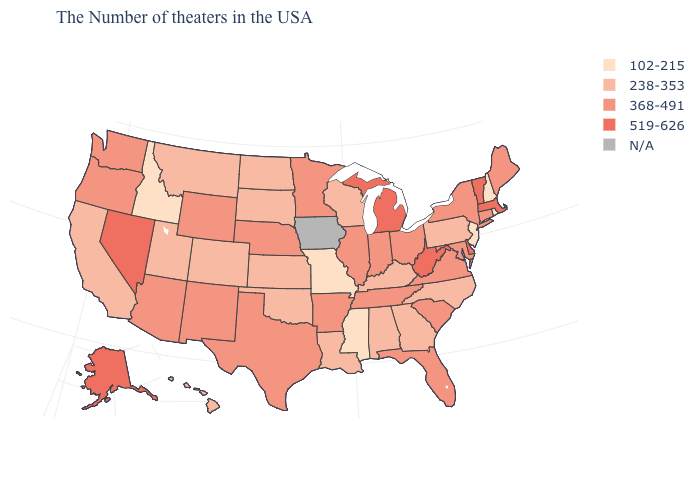What is the value of Georgia?
Give a very brief answer. 238-353. Is the legend a continuous bar?
Give a very brief answer. No. What is the lowest value in the USA?
Give a very brief answer. 102-215. Among the states that border Maine , which have the lowest value?
Concise answer only. New Hampshire. What is the value of Hawaii?
Short answer required. 238-353. Among the states that border Louisiana , does Mississippi have the lowest value?
Keep it brief. Yes. What is the value of South Dakota?
Give a very brief answer. 238-353. Among the states that border Missouri , which have the highest value?
Answer briefly. Tennessee, Illinois, Arkansas, Nebraska. Does the map have missing data?
Answer briefly. Yes. Does Colorado have the lowest value in the USA?
Concise answer only. No. Is the legend a continuous bar?
Concise answer only. No. What is the value of Wyoming?
Concise answer only. 368-491. What is the highest value in the Northeast ?
Quick response, please. 519-626. 